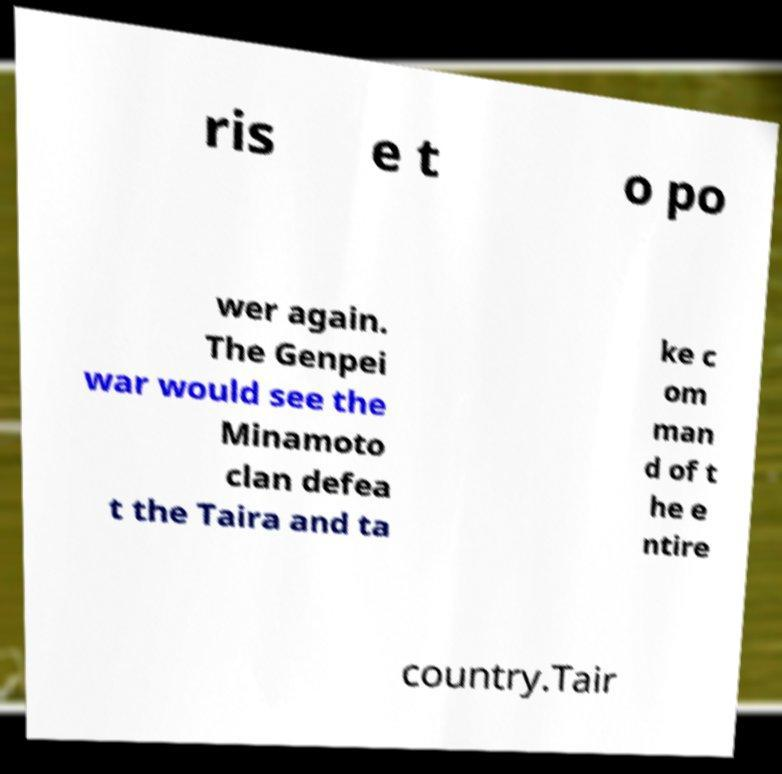Please identify and transcribe the text found in this image. ris e t o po wer again. The Genpei war would see the Minamoto clan defea t the Taira and ta ke c om man d of t he e ntire country.Tair 